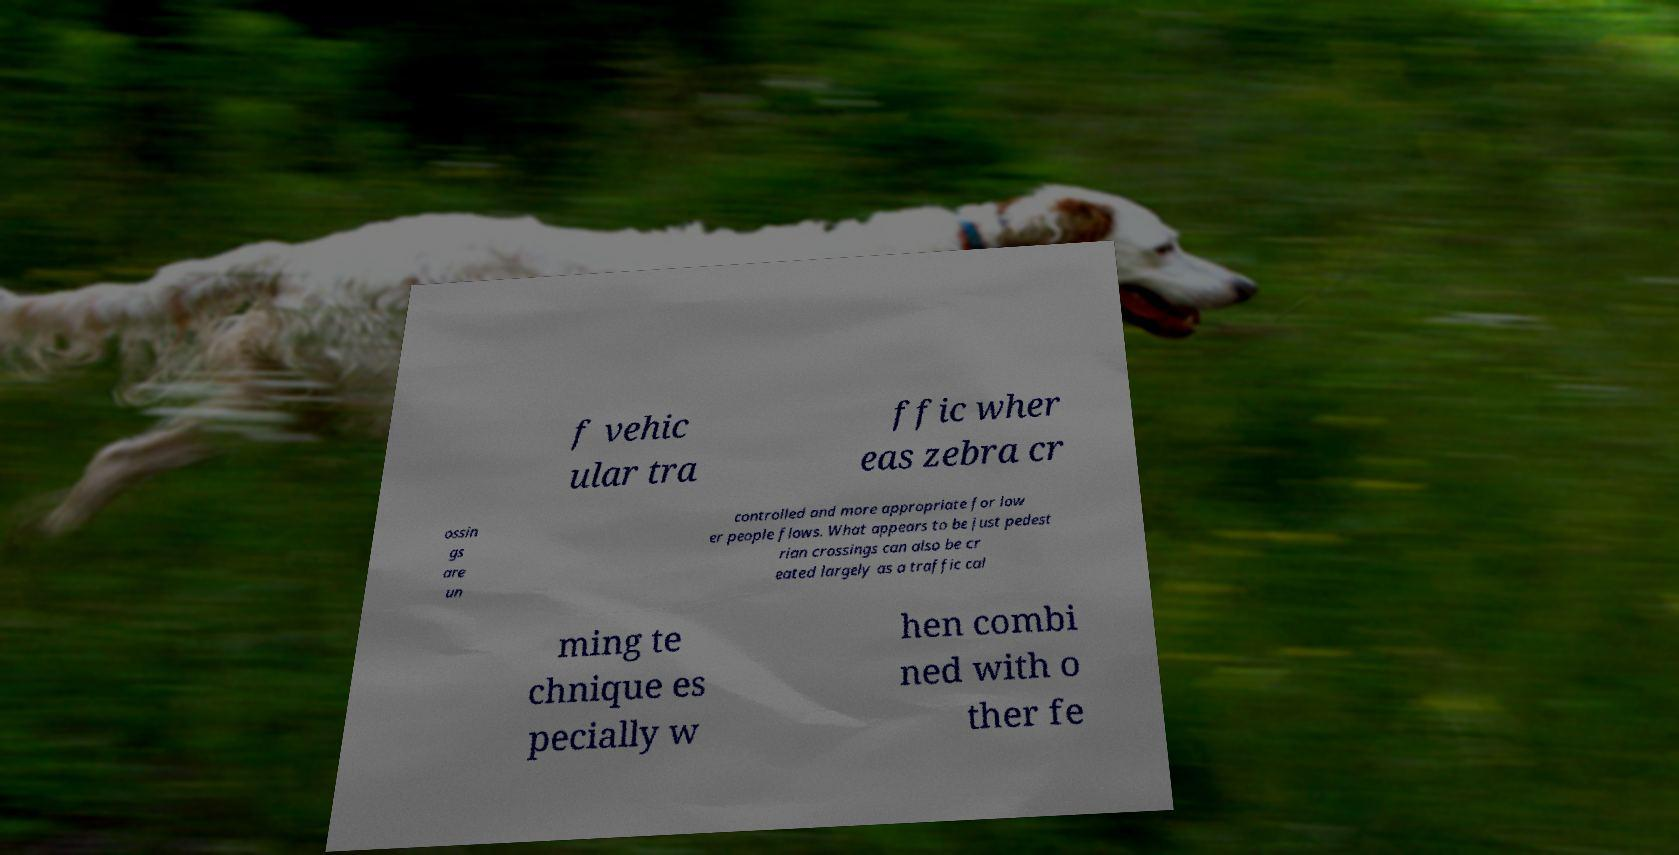Could you extract and type out the text from this image? f vehic ular tra ffic wher eas zebra cr ossin gs are un controlled and more appropriate for low er people flows. What appears to be just pedest rian crossings can also be cr eated largely as a traffic cal ming te chnique es pecially w hen combi ned with o ther fe 